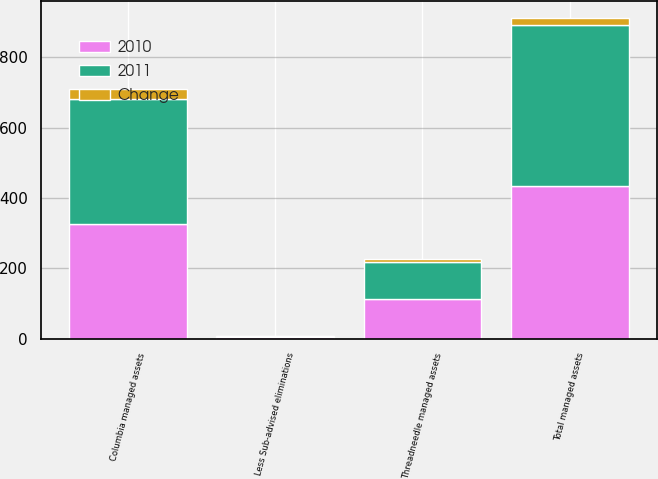Convert chart. <chart><loc_0><loc_0><loc_500><loc_500><stacked_bar_chart><ecel><fcel>Columbia managed assets<fcel>Threadneedle managed assets<fcel>Less Sub-advised eliminations<fcel>Total managed assets<nl><fcel>2010<fcel>326.1<fcel>113.6<fcel>4.2<fcel>435.5<nl><fcel>2011<fcel>355.5<fcel>105.6<fcel>4.3<fcel>456.8<nl><fcel>Change<fcel>29.4<fcel>8<fcel>0.1<fcel>21.3<nl></chart> 